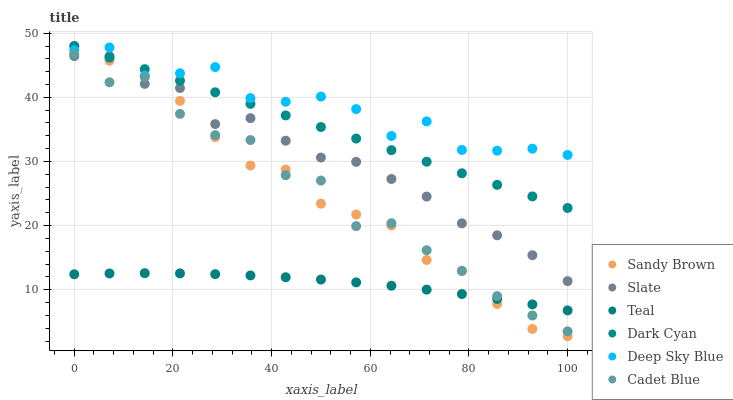Does Teal have the minimum area under the curve?
Answer yes or no. Yes. Does Deep Sky Blue have the maximum area under the curve?
Answer yes or no. Yes. Does Slate have the minimum area under the curve?
Answer yes or no. No. Does Slate have the maximum area under the curve?
Answer yes or no. No. Is Dark Cyan the smoothest?
Answer yes or no. Yes. Is Cadet Blue the roughest?
Answer yes or no. Yes. Is Teal the smoothest?
Answer yes or no. No. Is Teal the roughest?
Answer yes or no. No. Does Sandy Brown have the lowest value?
Answer yes or no. Yes. Does Teal have the lowest value?
Answer yes or no. No. Does Sandy Brown have the highest value?
Answer yes or no. Yes. Does Slate have the highest value?
Answer yes or no. No. Is Slate less than Deep Sky Blue?
Answer yes or no. Yes. Is Deep Sky Blue greater than Teal?
Answer yes or no. Yes. Does Cadet Blue intersect Teal?
Answer yes or no. Yes. Is Cadet Blue less than Teal?
Answer yes or no. No. Is Cadet Blue greater than Teal?
Answer yes or no. No. Does Slate intersect Deep Sky Blue?
Answer yes or no. No. 